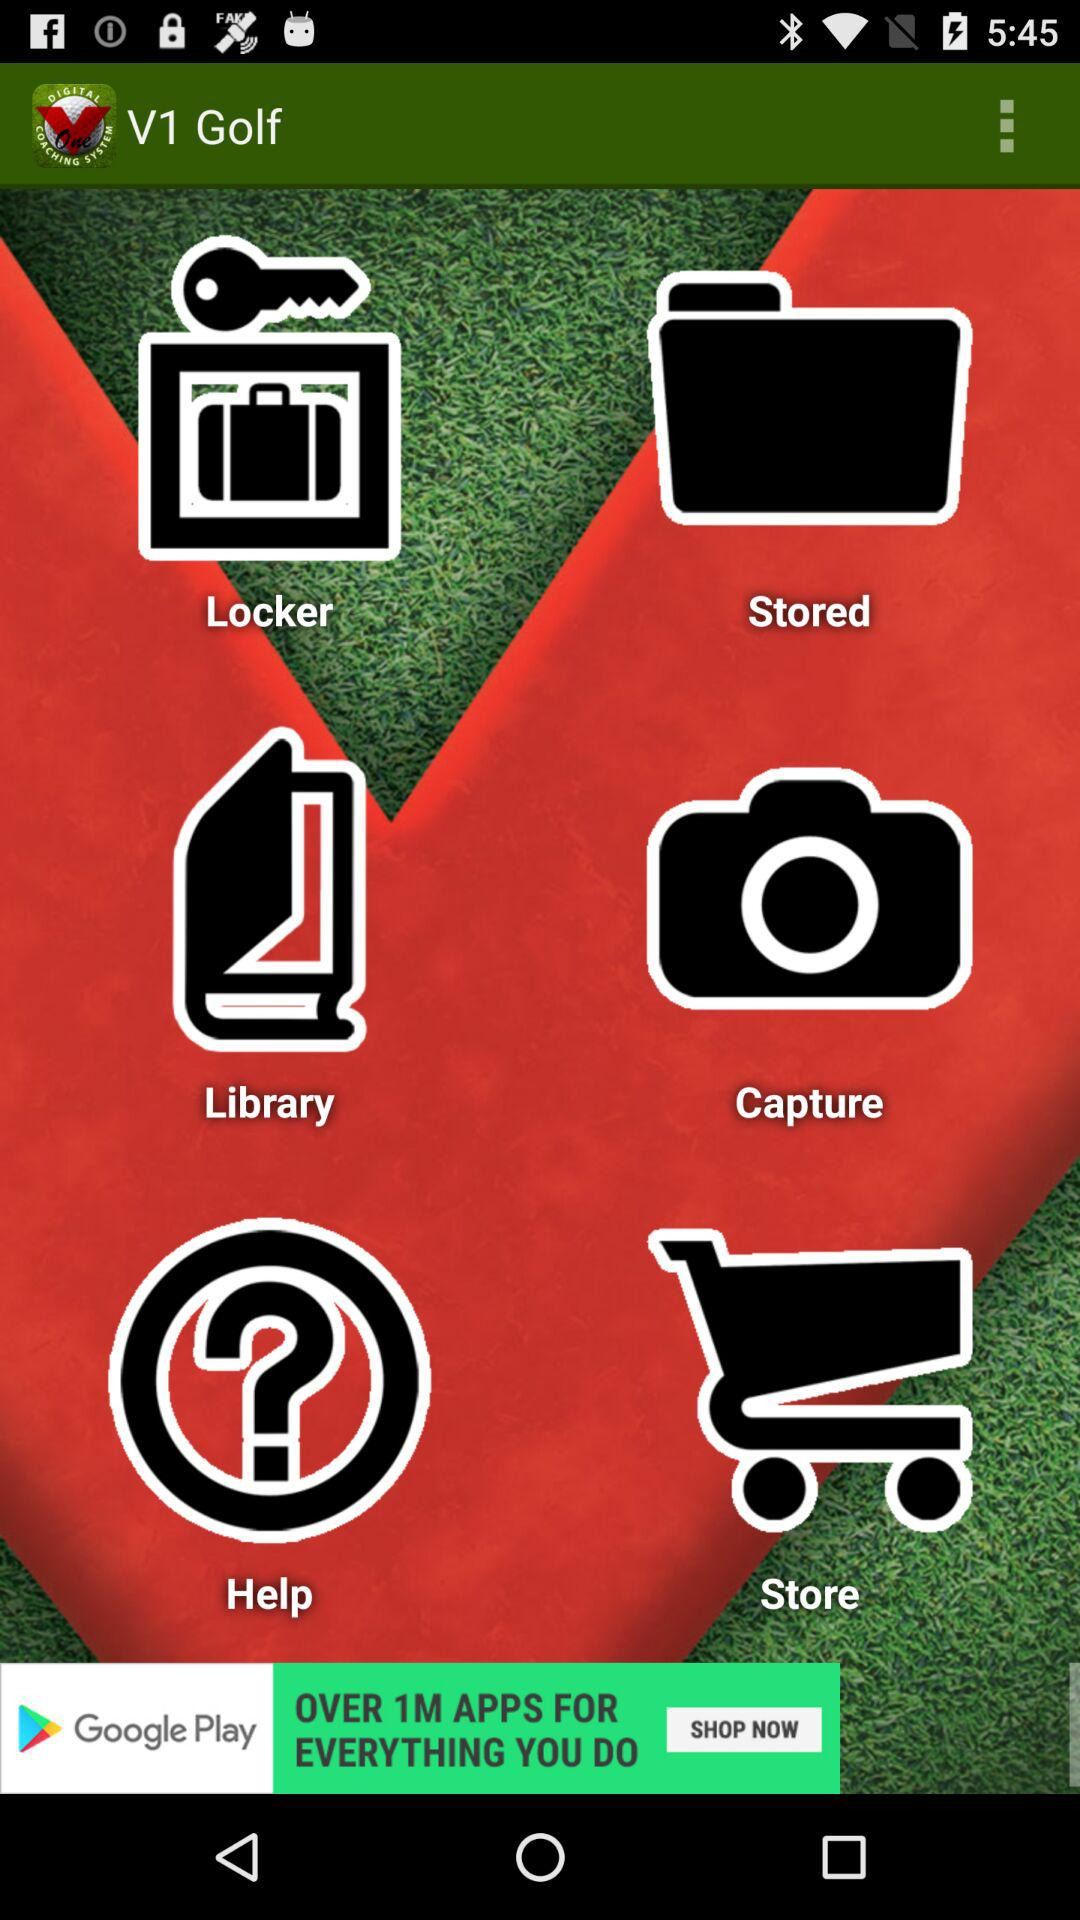What is the application name? The application name is "V1 Golf". 